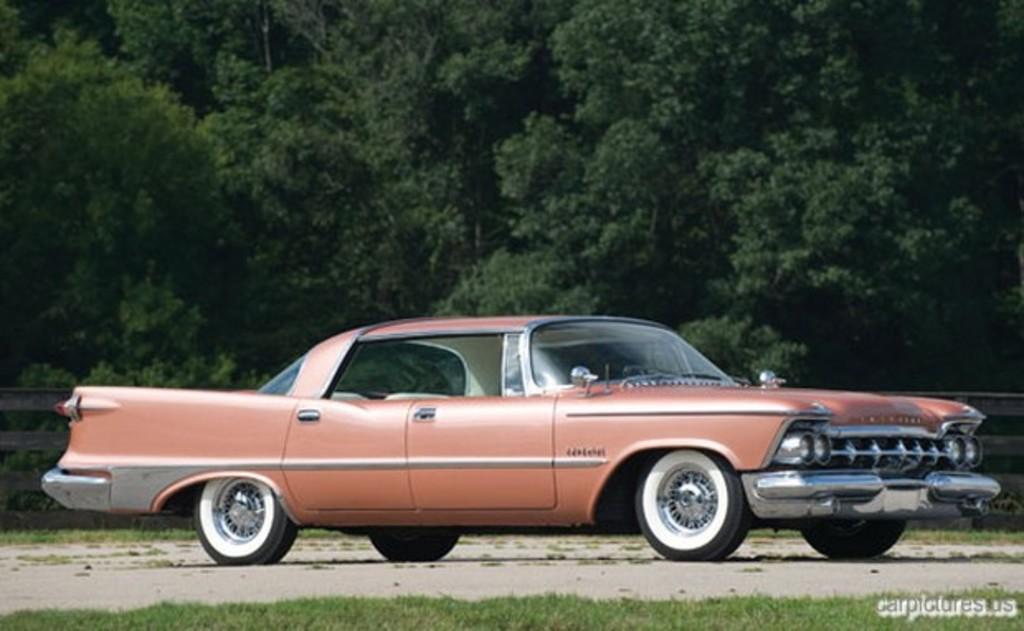How would you summarize this image in a sentence or two? In the center of the image there is a car on the road. At the bottom there is grass. In the background there are trees and we can see a fence. 